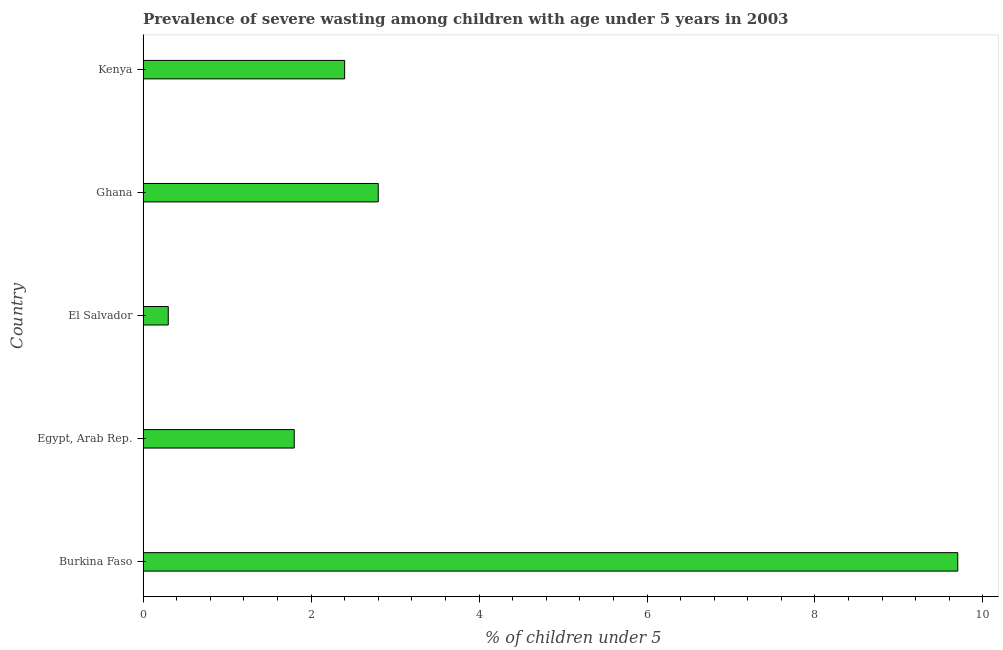Does the graph contain any zero values?
Provide a succinct answer. No. Does the graph contain grids?
Keep it short and to the point. No. What is the title of the graph?
Keep it short and to the point. Prevalence of severe wasting among children with age under 5 years in 2003. What is the label or title of the X-axis?
Your answer should be compact.  % of children under 5. What is the prevalence of severe wasting in Kenya?
Give a very brief answer. 2.4. Across all countries, what is the maximum prevalence of severe wasting?
Offer a very short reply. 9.7. Across all countries, what is the minimum prevalence of severe wasting?
Your answer should be very brief. 0.3. In which country was the prevalence of severe wasting maximum?
Give a very brief answer. Burkina Faso. In which country was the prevalence of severe wasting minimum?
Ensure brevity in your answer.  El Salvador. What is the sum of the prevalence of severe wasting?
Your response must be concise. 17. What is the difference between the prevalence of severe wasting in Burkina Faso and Kenya?
Keep it short and to the point. 7.3. What is the average prevalence of severe wasting per country?
Provide a short and direct response. 3.4. What is the median prevalence of severe wasting?
Your answer should be compact. 2.4. In how many countries, is the prevalence of severe wasting greater than 4.8 %?
Give a very brief answer. 1. What is the ratio of the prevalence of severe wasting in Ghana to that in Kenya?
Offer a very short reply. 1.17. Is the difference between the prevalence of severe wasting in Burkina Faso and Ghana greater than the difference between any two countries?
Your answer should be very brief. No. What is the difference between the highest and the second highest prevalence of severe wasting?
Provide a short and direct response. 6.9. Is the sum of the prevalence of severe wasting in Egypt, Arab Rep. and Ghana greater than the maximum prevalence of severe wasting across all countries?
Your response must be concise. No. What is the difference between the highest and the lowest prevalence of severe wasting?
Provide a short and direct response. 9.4. In how many countries, is the prevalence of severe wasting greater than the average prevalence of severe wasting taken over all countries?
Provide a succinct answer. 1. Are all the bars in the graph horizontal?
Provide a succinct answer. Yes. What is the difference between two consecutive major ticks on the X-axis?
Your answer should be compact. 2. What is the  % of children under 5 of Burkina Faso?
Provide a short and direct response. 9.7. What is the  % of children under 5 of Egypt, Arab Rep.?
Make the answer very short. 1.8. What is the  % of children under 5 of El Salvador?
Give a very brief answer. 0.3. What is the  % of children under 5 in Ghana?
Your answer should be very brief. 2.8. What is the  % of children under 5 in Kenya?
Your response must be concise. 2.4. What is the difference between the  % of children under 5 in Burkina Faso and El Salvador?
Your answer should be very brief. 9.4. What is the difference between the  % of children under 5 in Burkina Faso and Kenya?
Provide a short and direct response. 7.3. What is the difference between the  % of children under 5 in Egypt, Arab Rep. and El Salvador?
Provide a succinct answer. 1.5. What is the difference between the  % of children under 5 in Egypt, Arab Rep. and Ghana?
Give a very brief answer. -1. What is the difference between the  % of children under 5 in Egypt, Arab Rep. and Kenya?
Your answer should be very brief. -0.6. What is the difference between the  % of children under 5 in El Salvador and Kenya?
Offer a terse response. -2.1. What is the difference between the  % of children under 5 in Ghana and Kenya?
Ensure brevity in your answer.  0.4. What is the ratio of the  % of children under 5 in Burkina Faso to that in Egypt, Arab Rep.?
Your response must be concise. 5.39. What is the ratio of the  % of children under 5 in Burkina Faso to that in El Salvador?
Make the answer very short. 32.33. What is the ratio of the  % of children under 5 in Burkina Faso to that in Ghana?
Make the answer very short. 3.46. What is the ratio of the  % of children under 5 in Burkina Faso to that in Kenya?
Ensure brevity in your answer.  4.04. What is the ratio of the  % of children under 5 in Egypt, Arab Rep. to that in Ghana?
Ensure brevity in your answer.  0.64. What is the ratio of the  % of children under 5 in El Salvador to that in Ghana?
Offer a very short reply. 0.11. What is the ratio of the  % of children under 5 in Ghana to that in Kenya?
Your answer should be very brief. 1.17. 